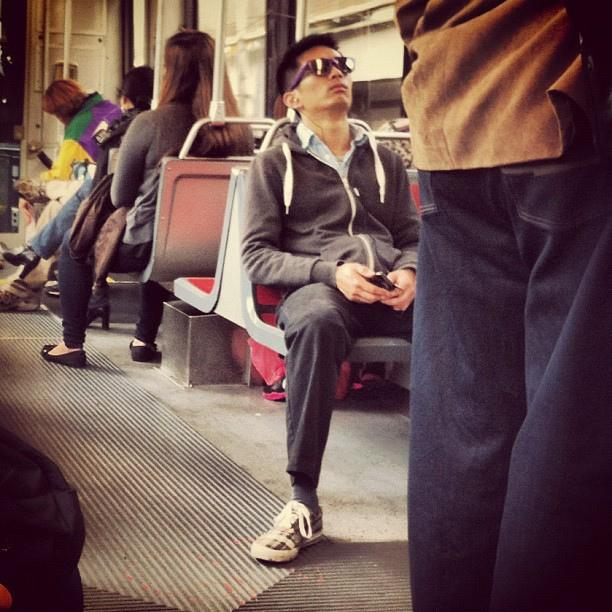How is the boy's sweater done up? zipper 